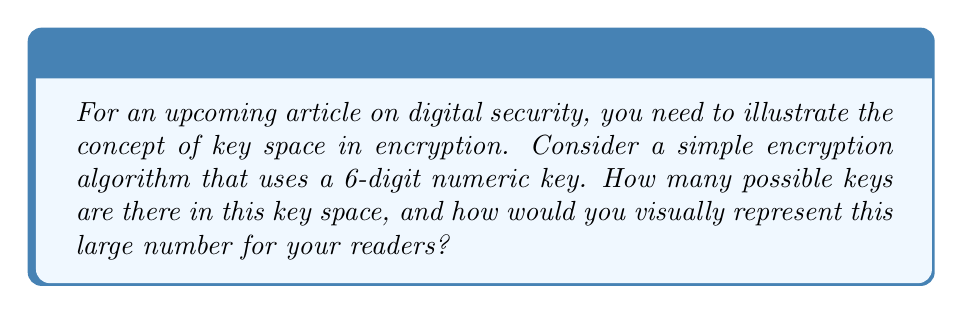Can you solve this math problem? To calculate the key space for this encryption algorithm, we need to determine the total number of possible 6-digit numeric keys:

1. Each digit in the key can be any number from 0 to 9, giving 10 possibilities for each digit.

2. The key has 6 digits, and each digit's choice is independent of the others.

3. We use the multiplication principle of counting. The total number of possible keys is:

   $$10 \times 10 \times 10 \times 10 \times 10 \times 10 = 10^6 = 1,000,000$$

4. To visually represent this large number for readers:
   - You could show a 100 x 100 grid, with each cell representing 100 keys.
   - Alternatively, you could illustrate it as a cube with 100 units on each side.

5. For a more relatable representation:
   - If each key were a grain of sand, 1,000,000 grains would fill approximately 1 liter or 1 quart container.
   - If each key were a second, it would take about 11.6 days to count through all possibilities.

These visual representations can help readers grasp the magnitude of the key space.
Answer: $10^6 = 1,000,000$ possible keys 